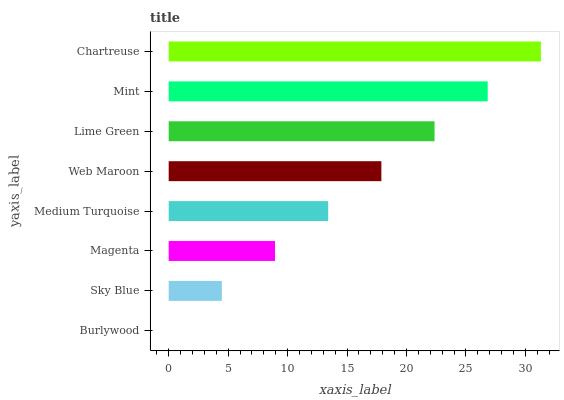Is Burlywood the minimum?
Answer yes or no. Yes. Is Chartreuse the maximum?
Answer yes or no. Yes. Is Sky Blue the minimum?
Answer yes or no. No. Is Sky Blue the maximum?
Answer yes or no. No. Is Sky Blue greater than Burlywood?
Answer yes or no. Yes. Is Burlywood less than Sky Blue?
Answer yes or no. Yes. Is Burlywood greater than Sky Blue?
Answer yes or no. No. Is Sky Blue less than Burlywood?
Answer yes or no. No. Is Web Maroon the high median?
Answer yes or no. Yes. Is Medium Turquoise the low median?
Answer yes or no. Yes. Is Sky Blue the high median?
Answer yes or no. No. Is Mint the low median?
Answer yes or no. No. 